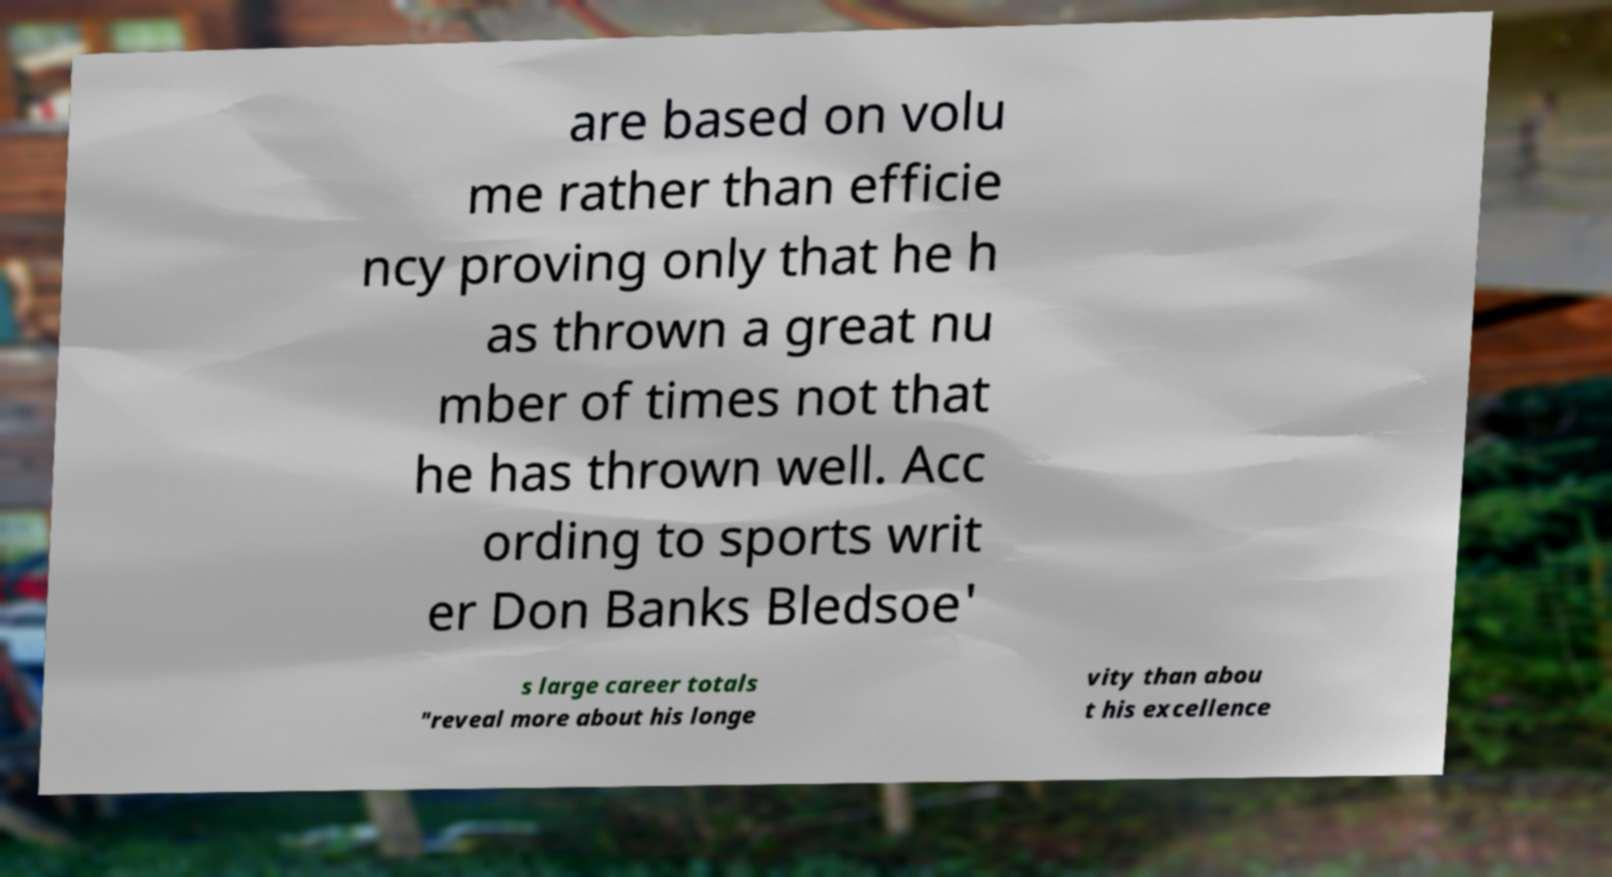Can you read and provide the text displayed in the image?This photo seems to have some interesting text. Can you extract and type it out for me? are based on volu me rather than efficie ncy proving only that he h as thrown a great nu mber of times not that he has thrown well. Acc ording to sports writ er Don Banks Bledsoe' s large career totals "reveal more about his longe vity than abou t his excellence 